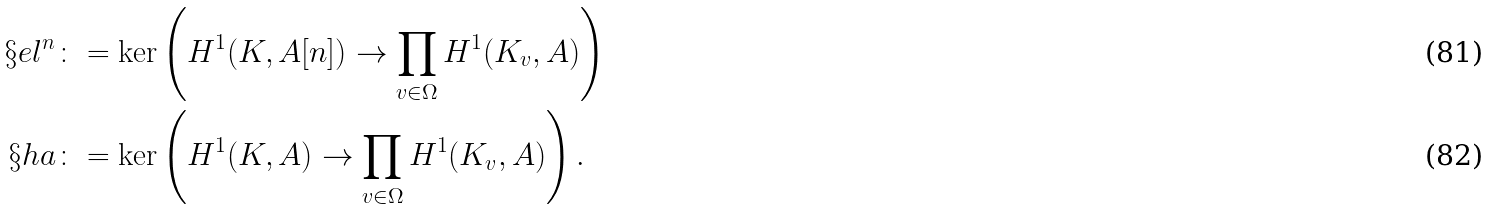Convert formula to latex. <formula><loc_0><loc_0><loc_500><loc_500>\S e l ^ { n } & \colon = \ker \left ( H ^ { 1 } ( K , A [ n ] ) \to \prod _ { v \in \Omega } H ^ { 1 } ( K _ { v } , A ) \right ) \\ \S h a & \colon = \ker \left ( H ^ { 1 } ( K , A ) \to \prod _ { v \in \Omega } H ^ { 1 } ( K _ { v } , A ) \right ) .</formula> 